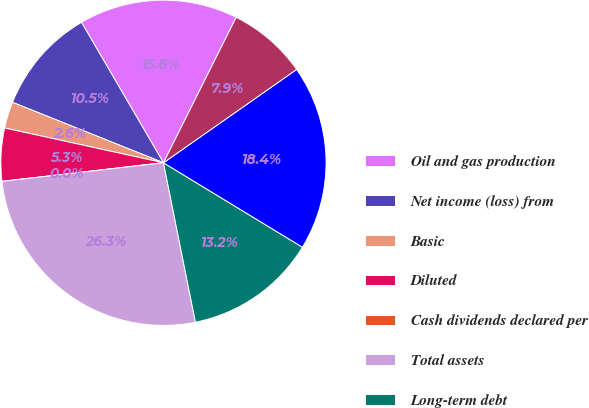Convert chart. <chart><loc_0><loc_0><loc_500><loc_500><pie_chart><fcel>Oil and gas production<fcel>Net income (loss) from<fcel>Basic<fcel>Diluted<fcel>Cash dividends declared per<fcel>Total assets<fcel>Long-term debt<fcel>Total equity<fcel>Common shares outstanding<nl><fcel>15.79%<fcel>10.53%<fcel>2.63%<fcel>5.26%<fcel>0.0%<fcel>26.32%<fcel>13.16%<fcel>18.42%<fcel>7.89%<nl></chart> 